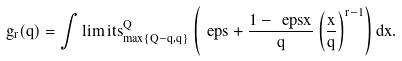<formula> <loc_0><loc_0><loc_500><loc_500>g _ { r } ( q ) = \int \lim i t s _ { \max \{ Q - q , q \} } ^ { Q } \left ( \ e p s + \frac { 1 - \ e p s x } { q } \left ( \frac { x } { q } \right ) ^ { r - 1 } \right ) d x .</formula> 